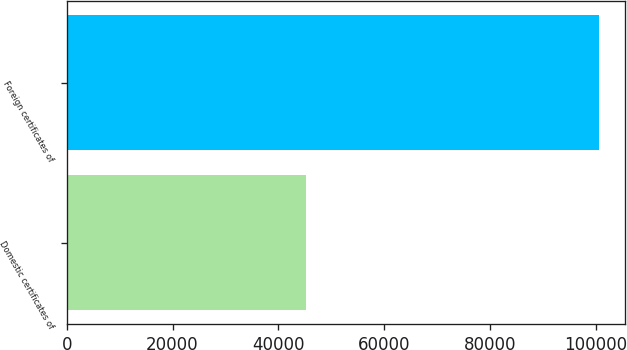<chart> <loc_0><loc_0><loc_500><loc_500><bar_chart><fcel>Domestic certificates of<fcel>Foreign certificates of<nl><fcel>45172<fcel>100515<nl></chart> 